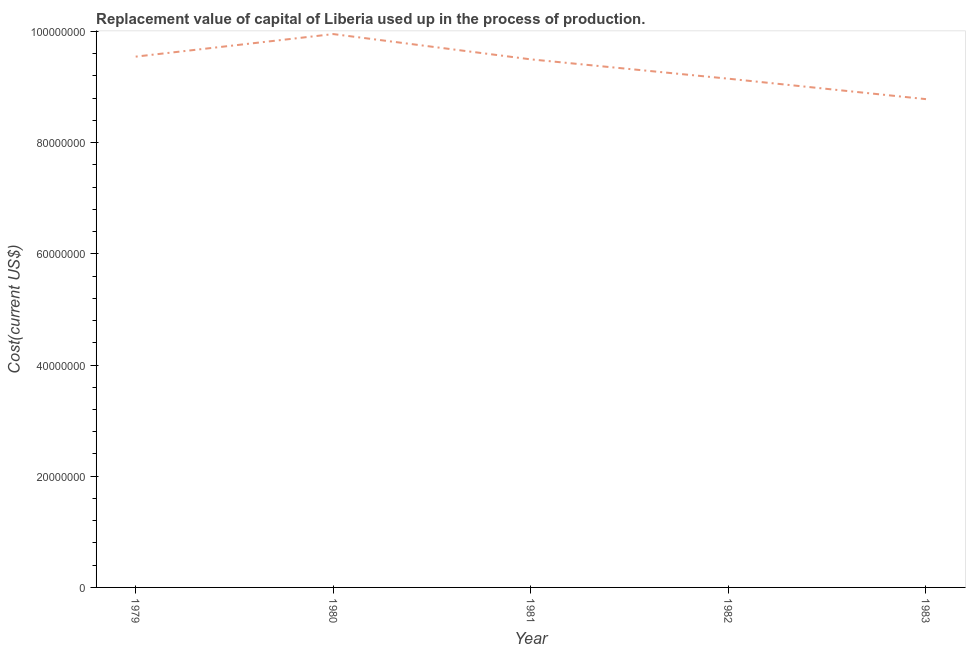What is the consumption of fixed capital in 1980?
Make the answer very short. 9.95e+07. Across all years, what is the maximum consumption of fixed capital?
Your response must be concise. 9.95e+07. Across all years, what is the minimum consumption of fixed capital?
Offer a terse response. 8.78e+07. What is the sum of the consumption of fixed capital?
Offer a very short reply. 4.69e+08. What is the difference between the consumption of fixed capital in 1980 and 1982?
Make the answer very short. 8.03e+06. What is the average consumption of fixed capital per year?
Provide a succinct answer. 9.39e+07. What is the median consumption of fixed capital?
Make the answer very short. 9.50e+07. In how many years, is the consumption of fixed capital greater than 36000000 US$?
Keep it short and to the point. 5. Do a majority of the years between 1979 and 1981 (inclusive) have consumption of fixed capital greater than 12000000 US$?
Provide a succinct answer. Yes. What is the ratio of the consumption of fixed capital in 1981 to that in 1982?
Keep it short and to the point. 1.04. Is the consumption of fixed capital in 1980 less than that in 1981?
Your answer should be very brief. No. Is the difference between the consumption of fixed capital in 1982 and 1983 greater than the difference between any two years?
Your response must be concise. No. What is the difference between the highest and the second highest consumption of fixed capital?
Your response must be concise. 4.06e+06. What is the difference between the highest and the lowest consumption of fixed capital?
Offer a terse response. 1.17e+07. In how many years, is the consumption of fixed capital greater than the average consumption of fixed capital taken over all years?
Provide a short and direct response. 3. Does the consumption of fixed capital monotonically increase over the years?
Your response must be concise. No. How many lines are there?
Offer a very short reply. 1. How many years are there in the graph?
Your response must be concise. 5. Are the values on the major ticks of Y-axis written in scientific E-notation?
Offer a terse response. No. Does the graph contain grids?
Ensure brevity in your answer.  No. What is the title of the graph?
Give a very brief answer. Replacement value of capital of Liberia used up in the process of production. What is the label or title of the X-axis?
Keep it short and to the point. Year. What is the label or title of the Y-axis?
Provide a short and direct response. Cost(current US$). What is the Cost(current US$) in 1979?
Offer a terse response. 9.55e+07. What is the Cost(current US$) of 1980?
Keep it short and to the point. 9.95e+07. What is the Cost(current US$) of 1981?
Your answer should be compact. 9.50e+07. What is the Cost(current US$) in 1982?
Give a very brief answer. 9.15e+07. What is the Cost(current US$) of 1983?
Your answer should be very brief. 8.78e+07. What is the difference between the Cost(current US$) in 1979 and 1980?
Your answer should be compact. -4.06e+06. What is the difference between the Cost(current US$) in 1979 and 1981?
Offer a terse response. 4.90e+05. What is the difference between the Cost(current US$) in 1979 and 1982?
Give a very brief answer. 3.97e+06. What is the difference between the Cost(current US$) in 1979 and 1983?
Your response must be concise. 7.65e+06. What is the difference between the Cost(current US$) in 1980 and 1981?
Provide a succinct answer. 4.55e+06. What is the difference between the Cost(current US$) in 1980 and 1982?
Give a very brief answer. 8.03e+06. What is the difference between the Cost(current US$) in 1980 and 1983?
Offer a terse response. 1.17e+07. What is the difference between the Cost(current US$) in 1981 and 1982?
Your answer should be compact. 3.48e+06. What is the difference between the Cost(current US$) in 1981 and 1983?
Your response must be concise. 7.16e+06. What is the difference between the Cost(current US$) in 1982 and 1983?
Your answer should be very brief. 3.68e+06. What is the ratio of the Cost(current US$) in 1979 to that in 1981?
Provide a succinct answer. 1. What is the ratio of the Cost(current US$) in 1979 to that in 1982?
Ensure brevity in your answer.  1.04. What is the ratio of the Cost(current US$) in 1979 to that in 1983?
Your answer should be very brief. 1.09. What is the ratio of the Cost(current US$) in 1980 to that in 1981?
Provide a short and direct response. 1.05. What is the ratio of the Cost(current US$) in 1980 to that in 1982?
Provide a succinct answer. 1.09. What is the ratio of the Cost(current US$) in 1980 to that in 1983?
Offer a very short reply. 1.13. What is the ratio of the Cost(current US$) in 1981 to that in 1982?
Your response must be concise. 1.04. What is the ratio of the Cost(current US$) in 1981 to that in 1983?
Your response must be concise. 1.08. What is the ratio of the Cost(current US$) in 1982 to that in 1983?
Give a very brief answer. 1.04. 